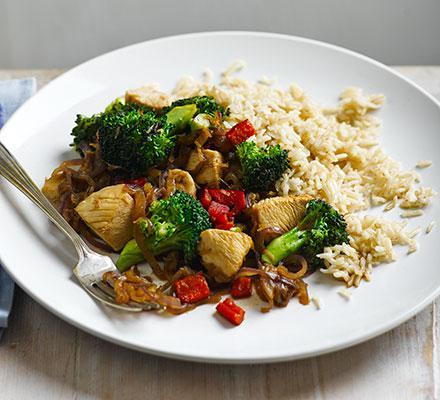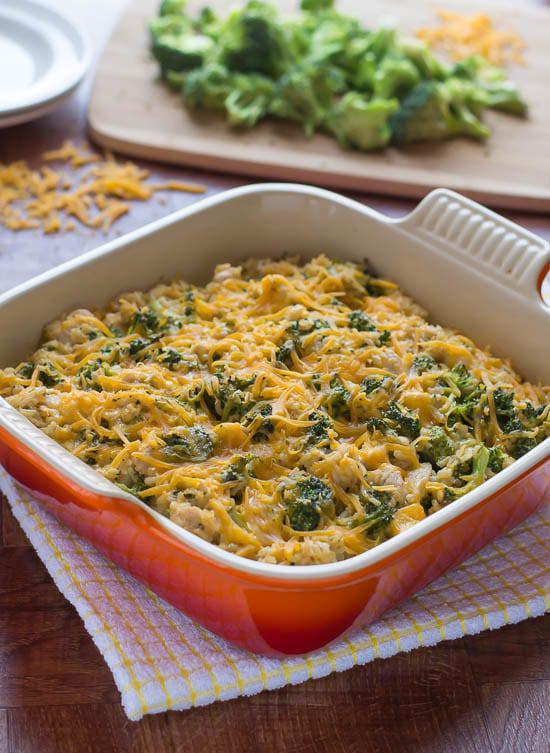The first image is the image on the left, the second image is the image on the right. Assess this claim about the two images: "There is a fork on one of the images.". Correct or not? Answer yes or no. Yes. 